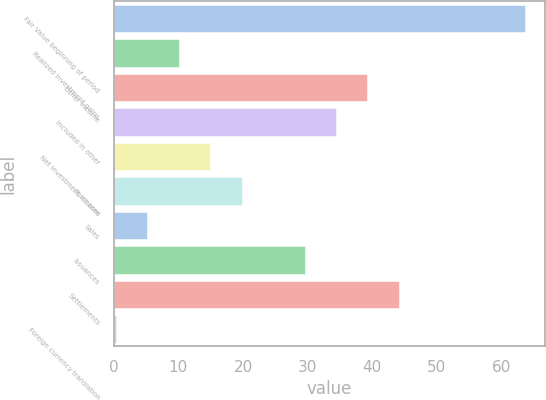Convert chart. <chart><loc_0><loc_0><loc_500><loc_500><bar_chart><fcel>Fair Value beginning of period<fcel>Realized investment gains<fcel>Other income<fcel>Included in other<fcel>Net investment income<fcel>Purchases<fcel>Sales<fcel>Issuances<fcel>Settlements<fcel>Foreign currency translation<nl><fcel>63.6<fcel>10.03<fcel>39.25<fcel>34.38<fcel>14.9<fcel>19.77<fcel>5.16<fcel>29.51<fcel>44.12<fcel>0.29<nl></chart> 